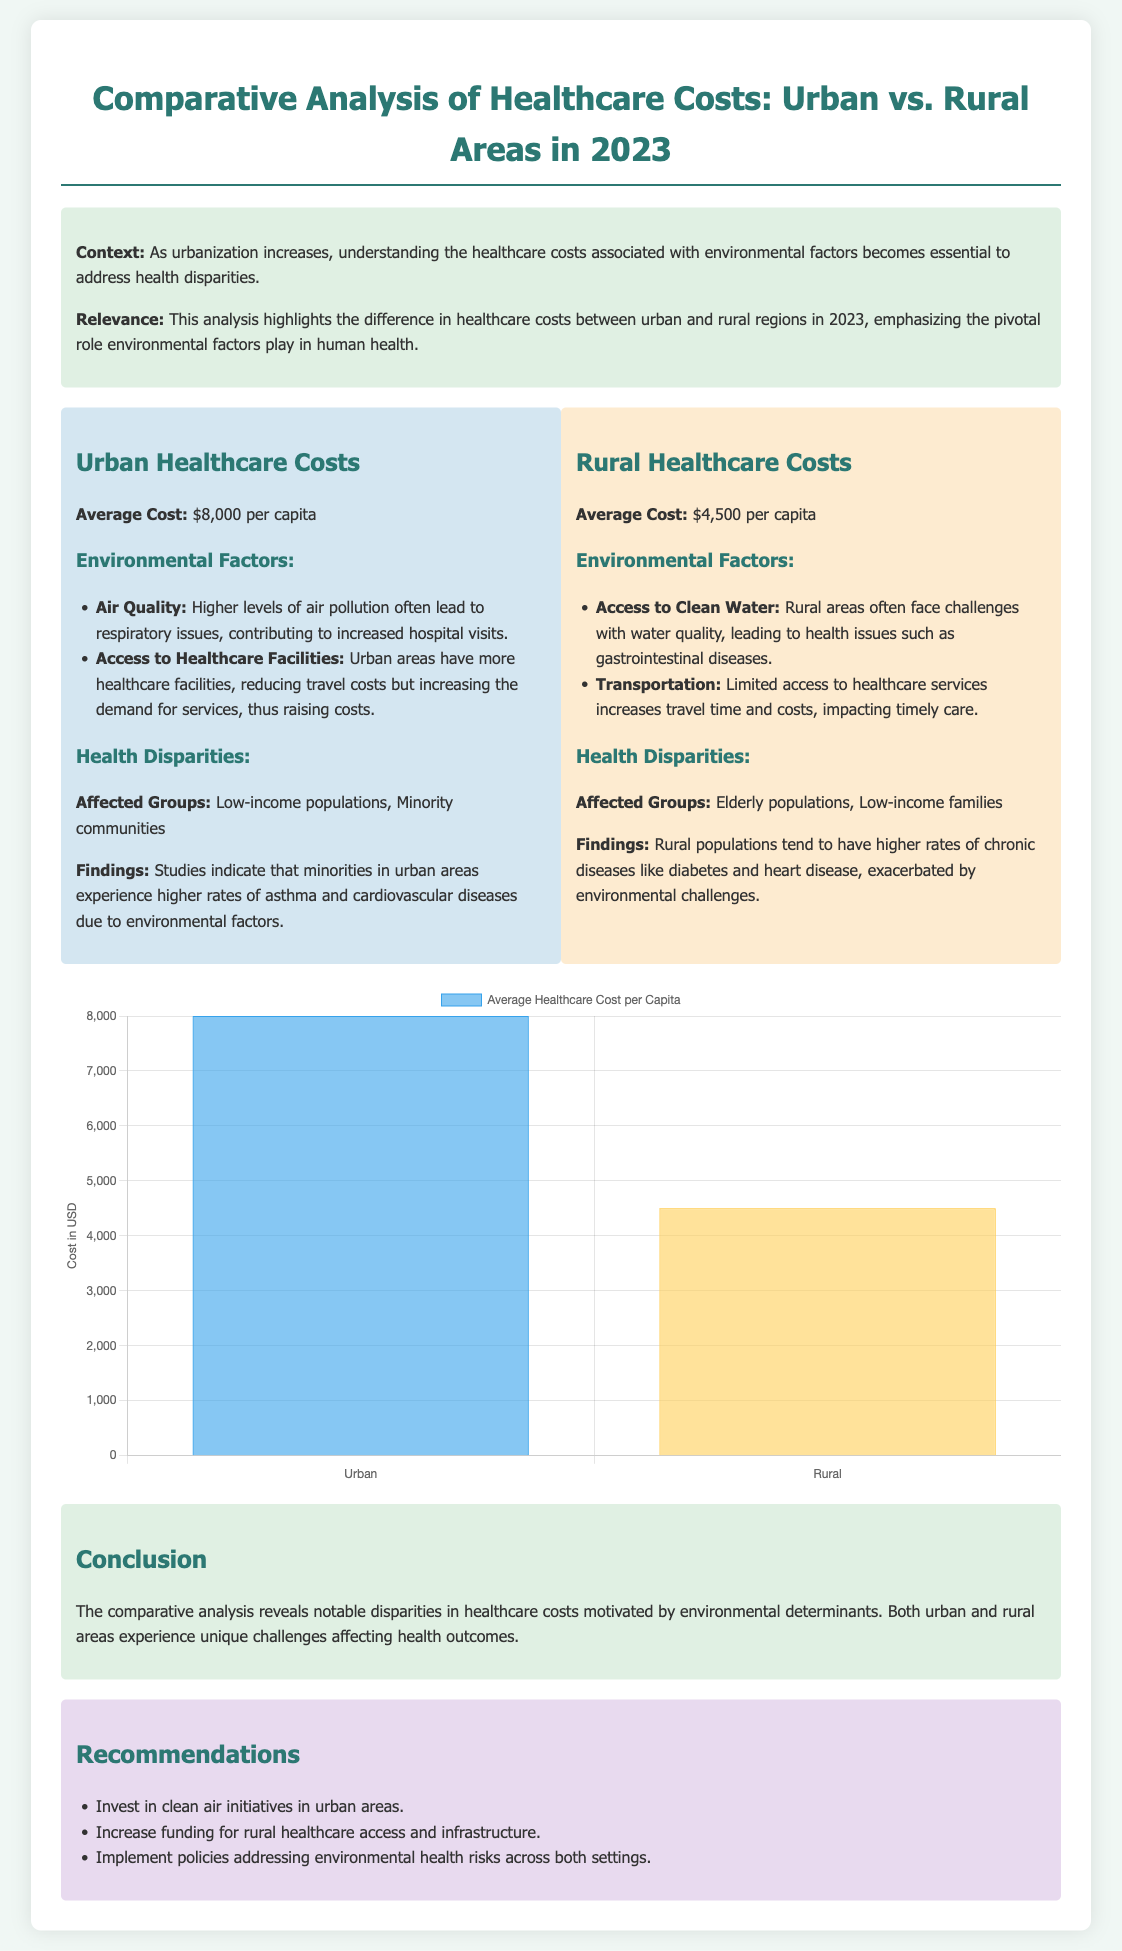What is the average healthcare cost in urban areas? The document states the average healthcare cost in urban areas is $8,000 per capita.
Answer: $8,000 What is the average healthcare cost in rural areas? According to the document, the average healthcare cost in rural areas is $4,500 per capita.
Answer: $4,500 Which community is particularly affected by health disparities in urban areas? The document specifies that minority communities are particularly affected by health disparities in urban areas.
Answer: Minority communities What environmental factor is linked to higher rates of gastrointestinal diseases in rural areas? The document notes that access to clean water is linked to higher rates of gastrointestinal diseases in rural areas.
Answer: Access to clean water What is one of the recommendations provided in the document? The document recommends increasing funding for rural healthcare access and infrastructure.
Answer: Increase funding for rural healthcare access and infrastructure What unique challenge affects health outcomes in rural areas? According to the document, limited access to healthcare services increases travel time and costs, which affects health outcomes in rural areas.
Answer: Limited access to healthcare services What environmental challenge is cited as a reason for higher healthcare costs in urban areas? The document mentions that higher levels of air pollution contribute to increased hospital visits in urban areas.
Answer: Air pollution How many categories of affected groups are mentioned in the rural section? The document lists two categories of affected groups in rural areas: elderly populations and low-income families.
Answer: Two categories 